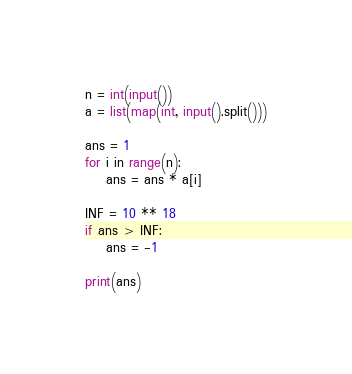Convert code to text. <code><loc_0><loc_0><loc_500><loc_500><_Python_>n = int(input())
a = list(map(int, input().split()))

ans = 1
for i in range(n):
    ans = ans * a[i]

INF = 10 ** 18
if ans > INF:
    ans = -1

print(ans)

</code> 